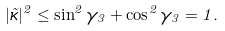<formula> <loc_0><loc_0><loc_500><loc_500>| \vec { \kappa } | ^ { 2 } \leq \sin ^ { 2 } \gamma _ { 3 } + \cos ^ { 2 } \gamma _ { 3 } = 1 .</formula> 